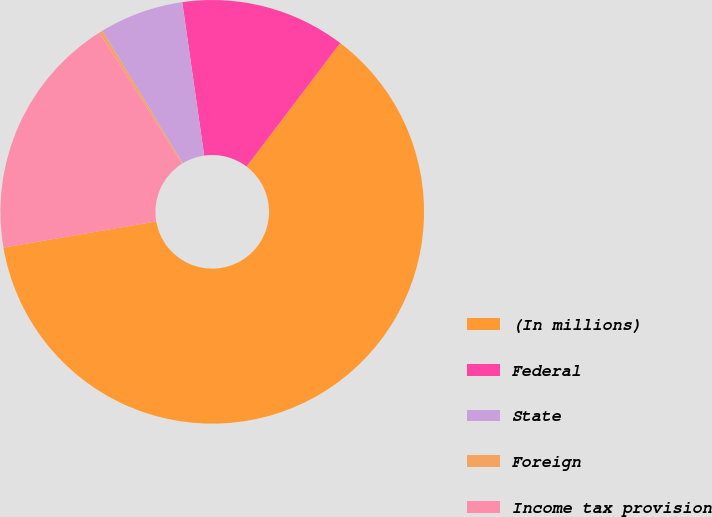Convert chart to OTSL. <chart><loc_0><loc_0><loc_500><loc_500><pie_chart><fcel>(In millions)<fcel>Federal<fcel>State<fcel>Foreign<fcel>Income tax provision<nl><fcel>61.98%<fcel>12.59%<fcel>6.42%<fcel>0.25%<fcel>18.77%<nl></chart> 